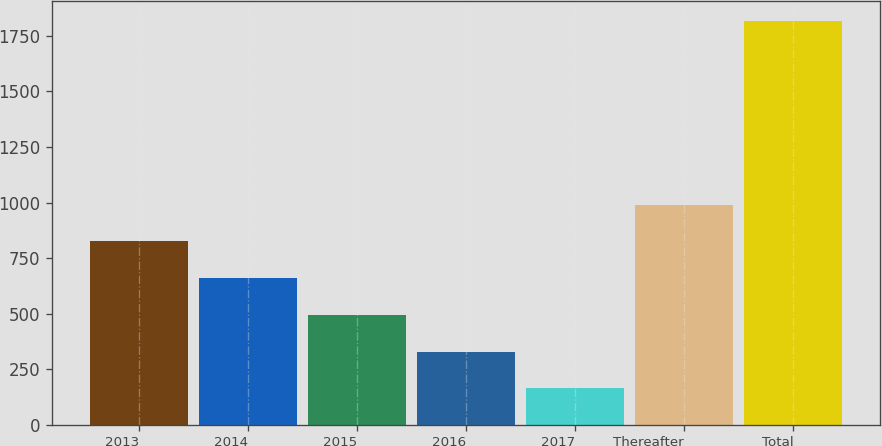Convert chart. <chart><loc_0><loc_0><loc_500><loc_500><bar_chart><fcel>2013<fcel>2014<fcel>2015<fcel>2016<fcel>2017<fcel>Thereafter<fcel>Total<nl><fcel>824.84<fcel>659.53<fcel>494.22<fcel>328.91<fcel>163.6<fcel>990.15<fcel>1816.7<nl></chart> 